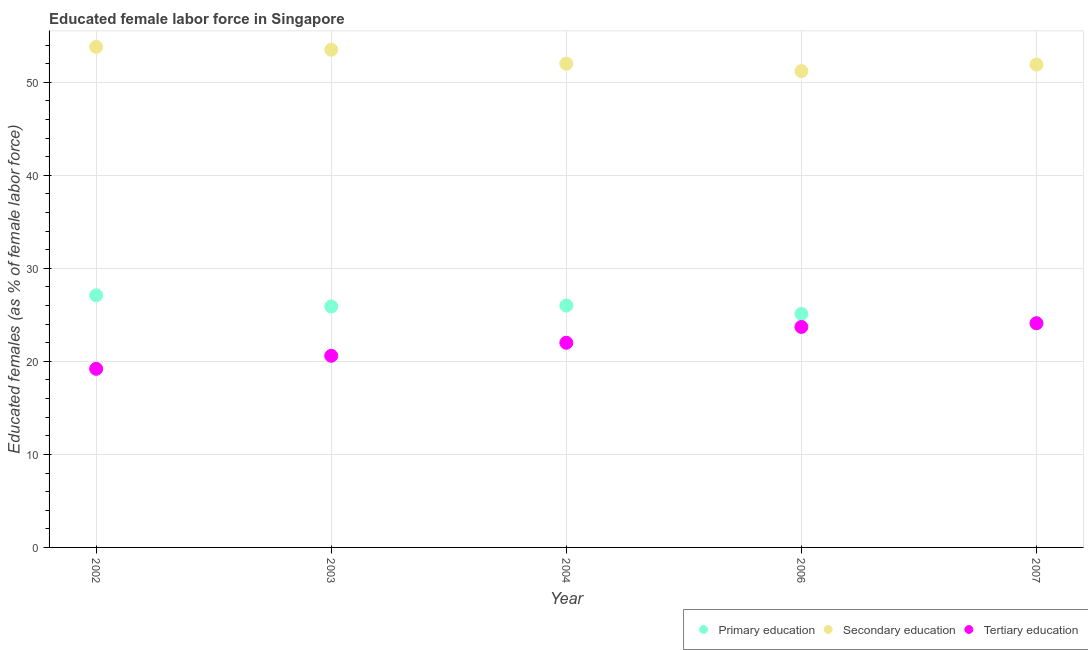Is the number of dotlines equal to the number of legend labels?
Ensure brevity in your answer.  Yes. What is the percentage of female labor force who received tertiary education in 2006?
Ensure brevity in your answer.  23.7. Across all years, what is the maximum percentage of female labor force who received tertiary education?
Provide a succinct answer. 24.1. Across all years, what is the minimum percentage of female labor force who received primary education?
Offer a terse response. 24.1. In which year was the percentage of female labor force who received tertiary education minimum?
Offer a terse response. 2002. What is the total percentage of female labor force who received tertiary education in the graph?
Keep it short and to the point. 109.6. What is the difference between the percentage of female labor force who received tertiary education in 2002 and that in 2003?
Offer a terse response. -1.4. What is the difference between the percentage of female labor force who received primary education in 2007 and the percentage of female labor force who received tertiary education in 2002?
Your answer should be compact. 4.9. What is the average percentage of female labor force who received secondary education per year?
Your answer should be compact. 52.48. In the year 2003, what is the difference between the percentage of female labor force who received primary education and percentage of female labor force who received secondary education?
Your answer should be compact. -27.6. In how many years, is the percentage of female labor force who received secondary education greater than 18 %?
Your answer should be very brief. 5. What is the ratio of the percentage of female labor force who received tertiary education in 2002 to that in 2004?
Offer a terse response. 0.87. Is the difference between the percentage of female labor force who received secondary education in 2003 and 2007 greater than the difference between the percentage of female labor force who received tertiary education in 2003 and 2007?
Provide a short and direct response. Yes. What is the difference between the highest and the second highest percentage of female labor force who received tertiary education?
Your answer should be very brief. 0.4. In how many years, is the percentage of female labor force who received primary education greater than the average percentage of female labor force who received primary education taken over all years?
Provide a succinct answer. 3. Is the sum of the percentage of female labor force who received secondary education in 2003 and 2007 greater than the maximum percentage of female labor force who received tertiary education across all years?
Your answer should be very brief. Yes. Is it the case that in every year, the sum of the percentage of female labor force who received primary education and percentage of female labor force who received secondary education is greater than the percentage of female labor force who received tertiary education?
Provide a short and direct response. Yes. Is the percentage of female labor force who received tertiary education strictly greater than the percentage of female labor force who received primary education over the years?
Give a very brief answer. No. How many years are there in the graph?
Make the answer very short. 5. What is the difference between two consecutive major ticks on the Y-axis?
Provide a succinct answer. 10. Are the values on the major ticks of Y-axis written in scientific E-notation?
Keep it short and to the point. No. Does the graph contain any zero values?
Ensure brevity in your answer.  No. Does the graph contain grids?
Ensure brevity in your answer.  Yes. Where does the legend appear in the graph?
Your answer should be very brief. Bottom right. How many legend labels are there?
Ensure brevity in your answer.  3. How are the legend labels stacked?
Provide a short and direct response. Horizontal. What is the title of the graph?
Offer a very short reply. Educated female labor force in Singapore. Does "Fuel" appear as one of the legend labels in the graph?
Your answer should be very brief. No. What is the label or title of the Y-axis?
Your answer should be compact. Educated females (as % of female labor force). What is the Educated females (as % of female labor force) in Primary education in 2002?
Ensure brevity in your answer.  27.1. What is the Educated females (as % of female labor force) of Secondary education in 2002?
Keep it short and to the point. 53.8. What is the Educated females (as % of female labor force) of Tertiary education in 2002?
Keep it short and to the point. 19.2. What is the Educated females (as % of female labor force) of Primary education in 2003?
Offer a terse response. 25.9. What is the Educated females (as % of female labor force) in Secondary education in 2003?
Provide a succinct answer. 53.5. What is the Educated females (as % of female labor force) in Tertiary education in 2003?
Make the answer very short. 20.6. What is the Educated females (as % of female labor force) in Primary education in 2004?
Provide a succinct answer. 26. What is the Educated females (as % of female labor force) in Secondary education in 2004?
Make the answer very short. 52. What is the Educated females (as % of female labor force) of Tertiary education in 2004?
Offer a terse response. 22. What is the Educated females (as % of female labor force) of Primary education in 2006?
Provide a succinct answer. 25.1. What is the Educated females (as % of female labor force) of Secondary education in 2006?
Give a very brief answer. 51.2. What is the Educated females (as % of female labor force) of Tertiary education in 2006?
Provide a succinct answer. 23.7. What is the Educated females (as % of female labor force) of Primary education in 2007?
Offer a very short reply. 24.1. What is the Educated females (as % of female labor force) of Secondary education in 2007?
Provide a succinct answer. 51.9. What is the Educated females (as % of female labor force) of Tertiary education in 2007?
Your response must be concise. 24.1. Across all years, what is the maximum Educated females (as % of female labor force) in Primary education?
Your response must be concise. 27.1. Across all years, what is the maximum Educated females (as % of female labor force) of Secondary education?
Your response must be concise. 53.8. Across all years, what is the maximum Educated females (as % of female labor force) of Tertiary education?
Keep it short and to the point. 24.1. Across all years, what is the minimum Educated females (as % of female labor force) of Primary education?
Ensure brevity in your answer.  24.1. Across all years, what is the minimum Educated females (as % of female labor force) in Secondary education?
Offer a very short reply. 51.2. Across all years, what is the minimum Educated females (as % of female labor force) in Tertiary education?
Your response must be concise. 19.2. What is the total Educated females (as % of female labor force) in Primary education in the graph?
Your response must be concise. 128.2. What is the total Educated females (as % of female labor force) of Secondary education in the graph?
Your answer should be very brief. 262.4. What is the total Educated females (as % of female labor force) in Tertiary education in the graph?
Your answer should be compact. 109.6. What is the difference between the Educated females (as % of female labor force) in Primary education in 2002 and that in 2003?
Provide a short and direct response. 1.2. What is the difference between the Educated females (as % of female labor force) in Secondary education in 2002 and that in 2003?
Your response must be concise. 0.3. What is the difference between the Educated females (as % of female labor force) of Primary education in 2002 and that in 2004?
Give a very brief answer. 1.1. What is the difference between the Educated females (as % of female labor force) in Secondary education in 2002 and that in 2004?
Keep it short and to the point. 1.8. What is the difference between the Educated females (as % of female labor force) of Tertiary education in 2002 and that in 2004?
Ensure brevity in your answer.  -2.8. What is the difference between the Educated females (as % of female labor force) of Secondary education in 2002 and that in 2006?
Give a very brief answer. 2.6. What is the difference between the Educated females (as % of female labor force) in Tertiary education in 2002 and that in 2006?
Keep it short and to the point. -4.5. What is the difference between the Educated females (as % of female labor force) of Primary education in 2002 and that in 2007?
Give a very brief answer. 3. What is the difference between the Educated females (as % of female labor force) of Primary education in 2003 and that in 2006?
Ensure brevity in your answer.  0.8. What is the difference between the Educated females (as % of female labor force) of Tertiary education in 2003 and that in 2006?
Your response must be concise. -3.1. What is the difference between the Educated females (as % of female labor force) of Primary education in 2003 and that in 2007?
Offer a terse response. 1.8. What is the difference between the Educated females (as % of female labor force) in Tertiary education in 2003 and that in 2007?
Give a very brief answer. -3.5. What is the difference between the Educated females (as % of female labor force) of Primary education in 2004 and that in 2006?
Your answer should be compact. 0.9. What is the difference between the Educated females (as % of female labor force) of Secondary education in 2004 and that in 2006?
Offer a very short reply. 0.8. What is the difference between the Educated females (as % of female labor force) of Primary education in 2004 and that in 2007?
Keep it short and to the point. 1.9. What is the difference between the Educated females (as % of female labor force) of Secondary education in 2004 and that in 2007?
Offer a very short reply. 0.1. What is the difference between the Educated females (as % of female labor force) of Tertiary education in 2004 and that in 2007?
Your response must be concise. -2.1. What is the difference between the Educated females (as % of female labor force) of Primary education in 2002 and the Educated females (as % of female labor force) of Secondary education in 2003?
Your answer should be compact. -26.4. What is the difference between the Educated females (as % of female labor force) in Primary education in 2002 and the Educated females (as % of female labor force) in Tertiary education in 2003?
Offer a terse response. 6.5. What is the difference between the Educated females (as % of female labor force) of Secondary education in 2002 and the Educated females (as % of female labor force) of Tertiary education in 2003?
Your response must be concise. 33.2. What is the difference between the Educated females (as % of female labor force) of Primary education in 2002 and the Educated females (as % of female labor force) of Secondary education in 2004?
Provide a succinct answer. -24.9. What is the difference between the Educated females (as % of female labor force) in Secondary education in 2002 and the Educated females (as % of female labor force) in Tertiary education in 2004?
Give a very brief answer. 31.8. What is the difference between the Educated females (as % of female labor force) in Primary education in 2002 and the Educated females (as % of female labor force) in Secondary education in 2006?
Your answer should be compact. -24.1. What is the difference between the Educated females (as % of female labor force) of Primary education in 2002 and the Educated females (as % of female labor force) of Tertiary education in 2006?
Your answer should be very brief. 3.4. What is the difference between the Educated females (as % of female labor force) in Secondary education in 2002 and the Educated females (as % of female labor force) in Tertiary education in 2006?
Offer a terse response. 30.1. What is the difference between the Educated females (as % of female labor force) of Primary education in 2002 and the Educated females (as % of female labor force) of Secondary education in 2007?
Provide a short and direct response. -24.8. What is the difference between the Educated females (as % of female labor force) in Secondary education in 2002 and the Educated females (as % of female labor force) in Tertiary education in 2007?
Offer a terse response. 29.7. What is the difference between the Educated females (as % of female labor force) of Primary education in 2003 and the Educated females (as % of female labor force) of Secondary education in 2004?
Give a very brief answer. -26.1. What is the difference between the Educated females (as % of female labor force) in Secondary education in 2003 and the Educated females (as % of female labor force) in Tertiary education in 2004?
Your response must be concise. 31.5. What is the difference between the Educated females (as % of female labor force) in Primary education in 2003 and the Educated females (as % of female labor force) in Secondary education in 2006?
Your response must be concise. -25.3. What is the difference between the Educated females (as % of female labor force) in Primary education in 2003 and the Educated females (as % of female labor force) in Tertiary education in 2006?
Provide a short and direct response. 2.2. What is the difference between the Educated females (as % of female labor force) of Secondary education in 2003 and the Educated females (as % of female labor force) of Tertiary education in 2006?
Your answer should be very brief. 29.8. What is the difference between the Educated females (as % of female labor force) in Primary education in 2003 and the Educated females (as % of female labor force) in Secondary education in 2007?
Ensure brevity in your answer.  -26. What is the difference between the Educated females (as % of female labor force) in Secondary education in 2003 and the Educated females (as % of female labor force) in Tertiary education in 2007?
Make the answer very short. 29.4. What is the difference between the Educated females (as % of female labor force) of Primary education in 2004 and the Educated females (as % of female labor force) of Secondary education in 2006?
Keep it short and to the point. -25.2. What is the difference between the Educated females (as % of female labor force) in Secondary education in 2004 and the Educated females (as % of female labor force) in Tertiary education in 2006?
Offer a terse response. 28.3. What is the difference between the Educated females (as % of female labor force) in Primary education in 2004 and the Educated females (as % of female labor force) in Secondary education in 2007?
Provide a succinct answer. -25.9. What is the difference between the Educated females (as % of female labor force) in Secondary education in 2004 and the Educated females (as % of female labor force) in Tertiary education in 2007?
Offer a very short reply. 27.9. What is the difference between the Educated females (as % of female labor force) of Primary education in 2006 and the Educated females (as % of female labor force) of Secondary education in 2007?
Provide a succinct answer. -26.8. What is the difference between the Educated females (as % of female labor force) in Secondary education in 2006 and the Educated females (as % of female labor force) in Tertiary education in 2007?
Offer a very short reply. 27.1. What is the average Educated females (as % of female labor force) of Primary education per year?
Your answer should be compact. 25.64. What is the average Educated females (as % of female labor force) in Secondary education per year?
Give a very brief answer. 52.48. What is the average Educated females (as % of female labor force) in Tertiary education per year?
Provide a short and direct response. 21.92. In the year 2002, what is the difference between the Educated females (as % of female labor force) of Primary education and Educated females (as % of female labor force) of Secondary education?
Ensure brevity in your answer.  -26.7. In the year 2002, what is the difference between the Educated females (as % of female labor force) of Primary education and Educated females (as % of female labor force) of Tertiary education?
Your response must be concise. 7.9. In the year 2002, what is the difference between the Educated females (as % of female labor force) in Secondary education and Educated females (as % of female labor force) in Tertiary education?
Offer a terse response. 34.6. In the year 2003, what is the difference between the Educated females (as % of female labor force) in Primary education and Educated females (as % of female labor force) in Secondary education?
Give a very brief answer. -27.6. In the year 2003, what is the difference between the Educated females (as % of female labor force) in Primary education and Educated females (as % of female labor force) in Tertiary education?
Keep it short and to the point. 5.3. In the year 2003, what is the difference between the Educated females (as % of female labor force) of Secondary education and Educated females (as % of female labor force) of Tertiary education?
Give a very brief answer. 32.9. In the year 2004, what is the difference between the Educated females (as % of female labor force) of Primary education and Educated females (as % of female labor force) of Secondary education?
Your response must be concise. -26. In the year 2004, what is the difference between the Educated females (as % of female labor force) of Primary education and Educated females (as % of female labor force) of Tertiary education?
Offer a terse response. 4. In the year 2006, what is the difference between the Educated females (as % of female labor force) in Primary education and Educated females (as % of female labor force) in Secondary education?
Make the answer very short. -26.1. In the year 2006, what is the difference between the Educated females (as % of female labor force) of Primary education and Educated females (as % of female labor force) of Tertiary education?
Make the answer very short. 1.4. In the year 2006, what is the difference between the Educated females (as % of female labor force) of Secondary education and Educated females (as % of female labor force) of Tertiary education?
Give a very brief answer. 27.5. In the year 2007, what is the difference between the Educated females (as % of female labor force) in Primary education and Educated females (as % of female labor force) in Secondary education?
Keep it short and to the point. -27.8. In the year 2007, what is the difference between the Educated females (as % of female labor force) in Secondary education and Educated females (as % of female labor force) in Tertiary education?
Offer a very short reply. 27.8. What is the ratio of the Educated females (as % of female labor force) of Primary education in 2002 to that in 2003?
Ensure brevity in your answer.  1.05. What is the ratio of the Educated females (as % of female labor force) in Secondary education in 2002 to that in 2003?
Offer a very short reply. 1.01. What is the ratio of the Educated females (as % of female labor force) in Tertiary education in 2002 to that in 2003?
Offer a terse response. 0.93. What is the ratio of the Educated females (as % of female labor force) of Primary education in 2002 to that in 2004?
Provide a succinct answer. 1.04. What is the ratio of the Educated females (as % of female labor force) in Secondary education in 2002 to that in 2004?
Your answer should be compact. 1.03. What is the ratio of the Educated females (as % of female labor force) of Tertiary education in 2002 to that in 2004?
Provide a succinct answer. 0.87. What is the ratio of the Educated females (as % of female labor force) in Primary education in 2002 to that in 2006?
Provide a succinct answer. 1.08. What is the ratio of the Educated females (as % of female labor force) in Secondary education in 2002 to that in 2006?
Provide a short and direct response. 1.05. What is the ratio of the Educated females (as % of female labor force) of Tertiary education in 2002 to that in 2006?
Keep it short and to the point. 0.81. What is the ratio of the Educated females (as % of female labor force) of Primary education in 2002 to that in 2007?
Your response must be concise. 1.12. What is the ratio of the Educated females (as % of female labor force) in Secondary education in 2002 to that in 2007?
Ensure brevity in your answer.  1.04. What is the ratio of the Educated females (as % of female labor force) of Tertiary education in 2002 to that in 2007?
Your answer should be compact. 0.8. What is the ratio of the Educated females (as % of female labor force) of Primary education in 2003 to that in 2004?
Offer a terse response. 1. What is the ratio of the Educated females (as % of female labor force) in Secondary education in 2003 to that in 2004?
Ensure brevity in your answer.  1.03. What is the ratio of the Educated females (as % of female labor force) in Tertiary education in 2003 to that in 2004?
Keep it short and to the point. 0.94. What is the ratio of the Educated females (as % of female labor force) in Primary education in 2003 to that in 2006?
Your response must be concise. 1.03. What is the ratio of the Educated females (as % of female labor force) of Secondary education in 2003 to that in 2006?
Provide a succinct answer. 1.04. What is the ratio of the Educated females (as % of female labor force) in Tertiary education in 2003 to that in 2006?
Ensure brevity in your answer.  0.87. What is the ratio of the Educated females (as % of female labor force) of Primary education in 2003 to that in 2007?
Offer a very short reply. 1.07. What is the ratio of the Educated females (as % of female labor force) in Secondary education in 2003 to that in 2007?
Your response must be concise. 1.03. What is the ratio of the Educated females (as % of female labor force) in Tertiary education in 2003 to that in 2007?
Your answer should be very brief. 0.85. What is the ratio of the Educated females (as % of female labor force) of Primary education in 2004 to that in 2006?
Offer a very short reply. 1.04. What is the ratio of the Educated females (as % of female labor force) of Secondary education in 2004 to that in 2006?
Your answer should be very brief. 1.02. What is the ratio of the Educated females (as % of female labor force) in Tertiary education in 2004 to that in 2006?
Your answer should be compact. 0.93. What is the ratio of the Educated females (as % of female labor force) in Primary education in 2004 to that in 2007?
Give a very brief answer. 1.08. What is the ratio of the Educated females (as % of female labor force) of Secondary education in 2004 to that in 2007?
Keep it short and to the point. 1. What is the ratio of the Educated females (as % of female labor force) in Tertiary education in 2004 to that in 2007?
Offer a terse response. 0.91. What is the ratio of the Educated females (as % of female labor force) in Primary education in 2006 to that in 2007?
Offer a very short reply. 1.04. What is the ratio of the Educated females (as % of female labor force) of Secondary education in 2006 to that in 2007?
Your answer should be very brief. 0.99. What is the ratio of the Educated females (as % of female labor force) in Tertiary education in 2006 to that in 2007?
Ensure brevity in your answer.  0.98. What is the difference between the highest and the second highest Educated females (as % of female labor force) in Primary education?
Ensure brevity in your answer.  1.1. What is the difference between the highest and the second highest Educated females (as % of female labor force) of Secondary education?
Your answer should be compact. 0.3. What is the difference between the highest and the second highest Educated females (as % of female labor force) in Tertiary education?
Make the answer very short. 0.4. What is the difference between the highest and the lowest Educated females (as % of female labor force) of Primary education?
Offer a very short reply. 3. What is the difference between the highest and the lowest Educated females (as % of female labor force) in Secondary education?
Offer a very short reply. 2.6. What is the difference between the highest and the lowest Educated females (as % of female labor force) of Tertiary education?
Make the answer very short. 4.9. 